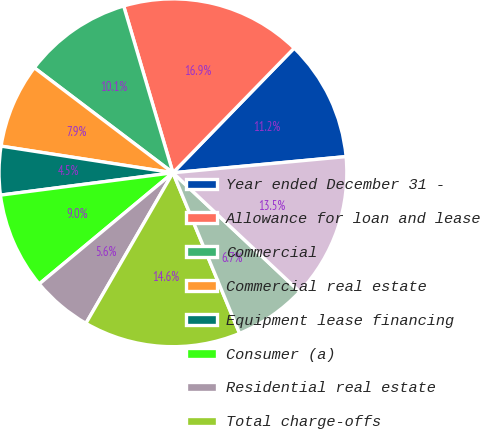Convert chart to OTSL. <chart><loc_0><loc_0><loc_500><loc_500><pie_chart><fcel>Year ended December 31 -<fcel>Allowance for loan and lease<fcel>Commercial<fcel>Commercial real estate<fcel>Equipment lease financing<fcel>Consumer (a)<fcel>Residential real estate<fcel>Total charge-offs<fcel>Total recoveries<fcel>Net charge-offs<nl><fcel>11.24%<fcel>16.85%<fcel>10.11%<fcel>7.87%<fcel>4.5%<fcel>8.99%<fcel>5.62%<fcel>14.6%<fcel>6.74%<fcel>13.48%<nl></chart> 